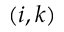<formula> <loc_0><loc_0><loc_500><loc_500>( i , k )</formula> 